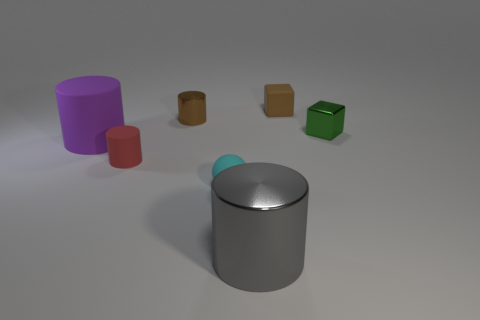How are the sizes of these objects related? The objects exhibit a range of sizes, from small to large. The small metallic ball is the smallest object, followed by the green cube and the two brown cylinders. The purple cylinder is slightly larger in diameter but shorter than the gray cylinder, which is the largest both in height and diameter among all present objects. 